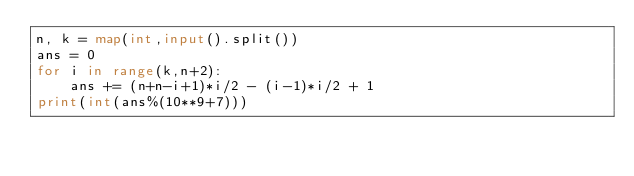<code> <loc_0><loc_0><loc_500><loc_500><_Python_>n, k = map(int,input().split())
ans = 0
for i in range(k,n+2):
    ans += (n+n-i+1)*i/2 - (i-1)*i/2 + 1
print(int(ans%(10**9+7)))</code> 